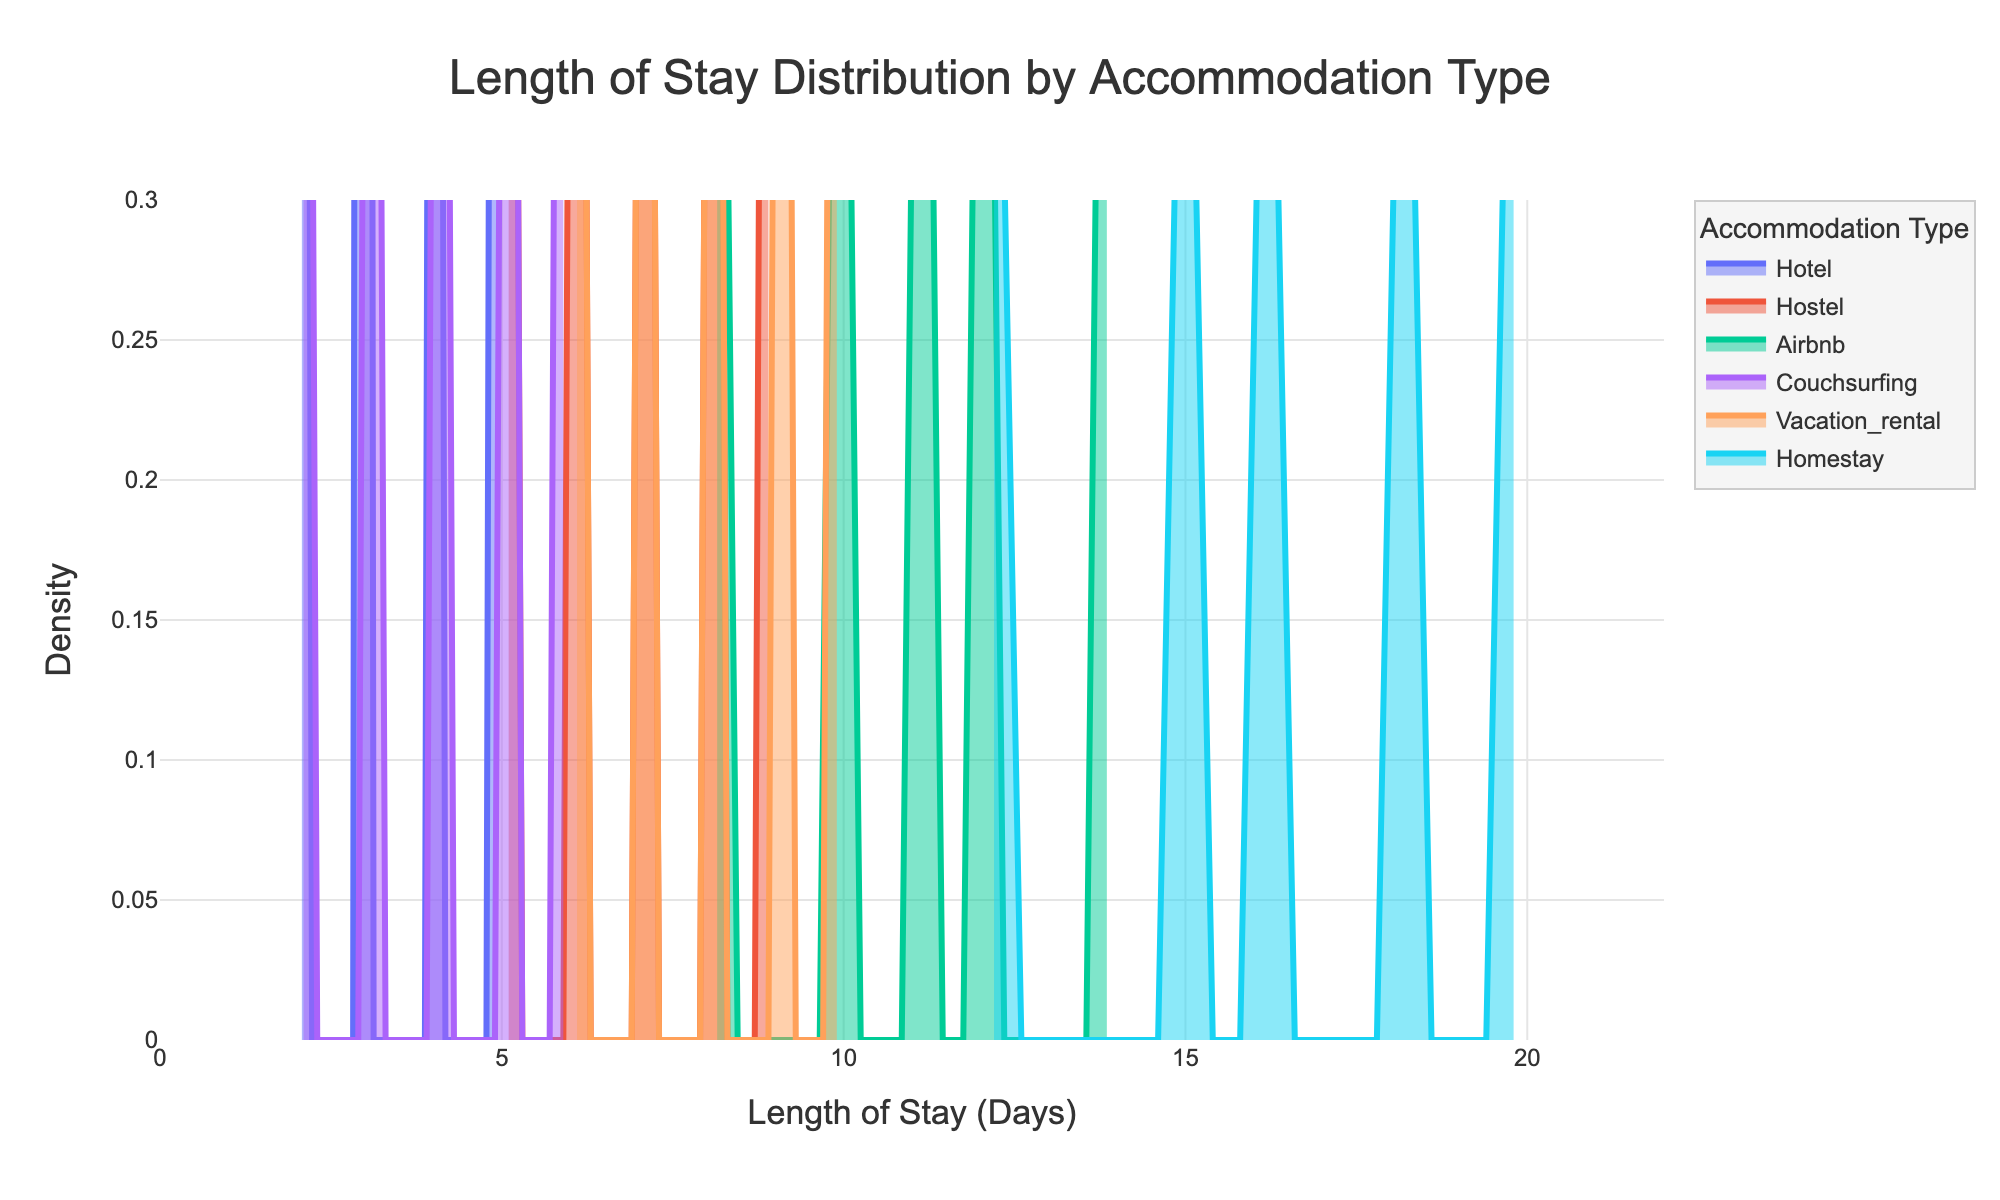What is the title of the plot? The title of the plot is usually displayed at the top and summarizes what the plot is about. It helps viewers quickly understand the subject of the visualization.
Answer: Length of Stay Distribution by Accommodation Type What does the x-axis represent in the plot? The x-axis in the plot shows the variable being measured horizontally, which represents the number of days for the length of stay.
Answer: Length of Stay (Days) Which accommodation type has the longest average length of stay? To determine the accommodation type with the longest average length of stay, we identify the distribution that is centered further to the right on the x-axis. In this plot, the distribution of "homestay" is centered at higher values on the x-axis compared to other types.
Answer: Homestay Which accommodation type has the shortest average length of stay? To find the accommodation type with the shortest average length of stay, we look for the distribution centered closest to the left on the x-axis. "Couchsurfing" shows a distribution centered at lower values on the x-axis.
Answer: Couchsurfing How do the density curves help understand the distribution of length of stay? Density curves show the distribution by smoothing the data points and indicating where the data is concentrated. Peaks in the density curves show where stays are more common for each accommodation type.
Answer: They indicate where length of stays are more common Which accommodation type shows the most variation in length of stay based on the plot? The variation in length of stay can be inferred from the spread of the density curve. A wider density curve implies more variation. "Airbnb" and "vacation_rental" both show wide spreads, but "Airbnb" has more noticeable tails extending further out.
Answer: Airbnb Is there an accommodation type that shows a bimodal or multimodal distribution? A bimodal or multimodal distribution would show multiple peaks. None of the accommodation types display clear multiple peaks in their density curves, indicating no strong bimodal or multimodal distributions.
Answer: No What is the range of length of stay for hotels visible in the plot? The range can be observed by looking at where the density of the hotel accommodation extends on the x-axis. The density curve for hotels broadly ranges between 2 to 5 days.
Answer: 2 to 5 days 